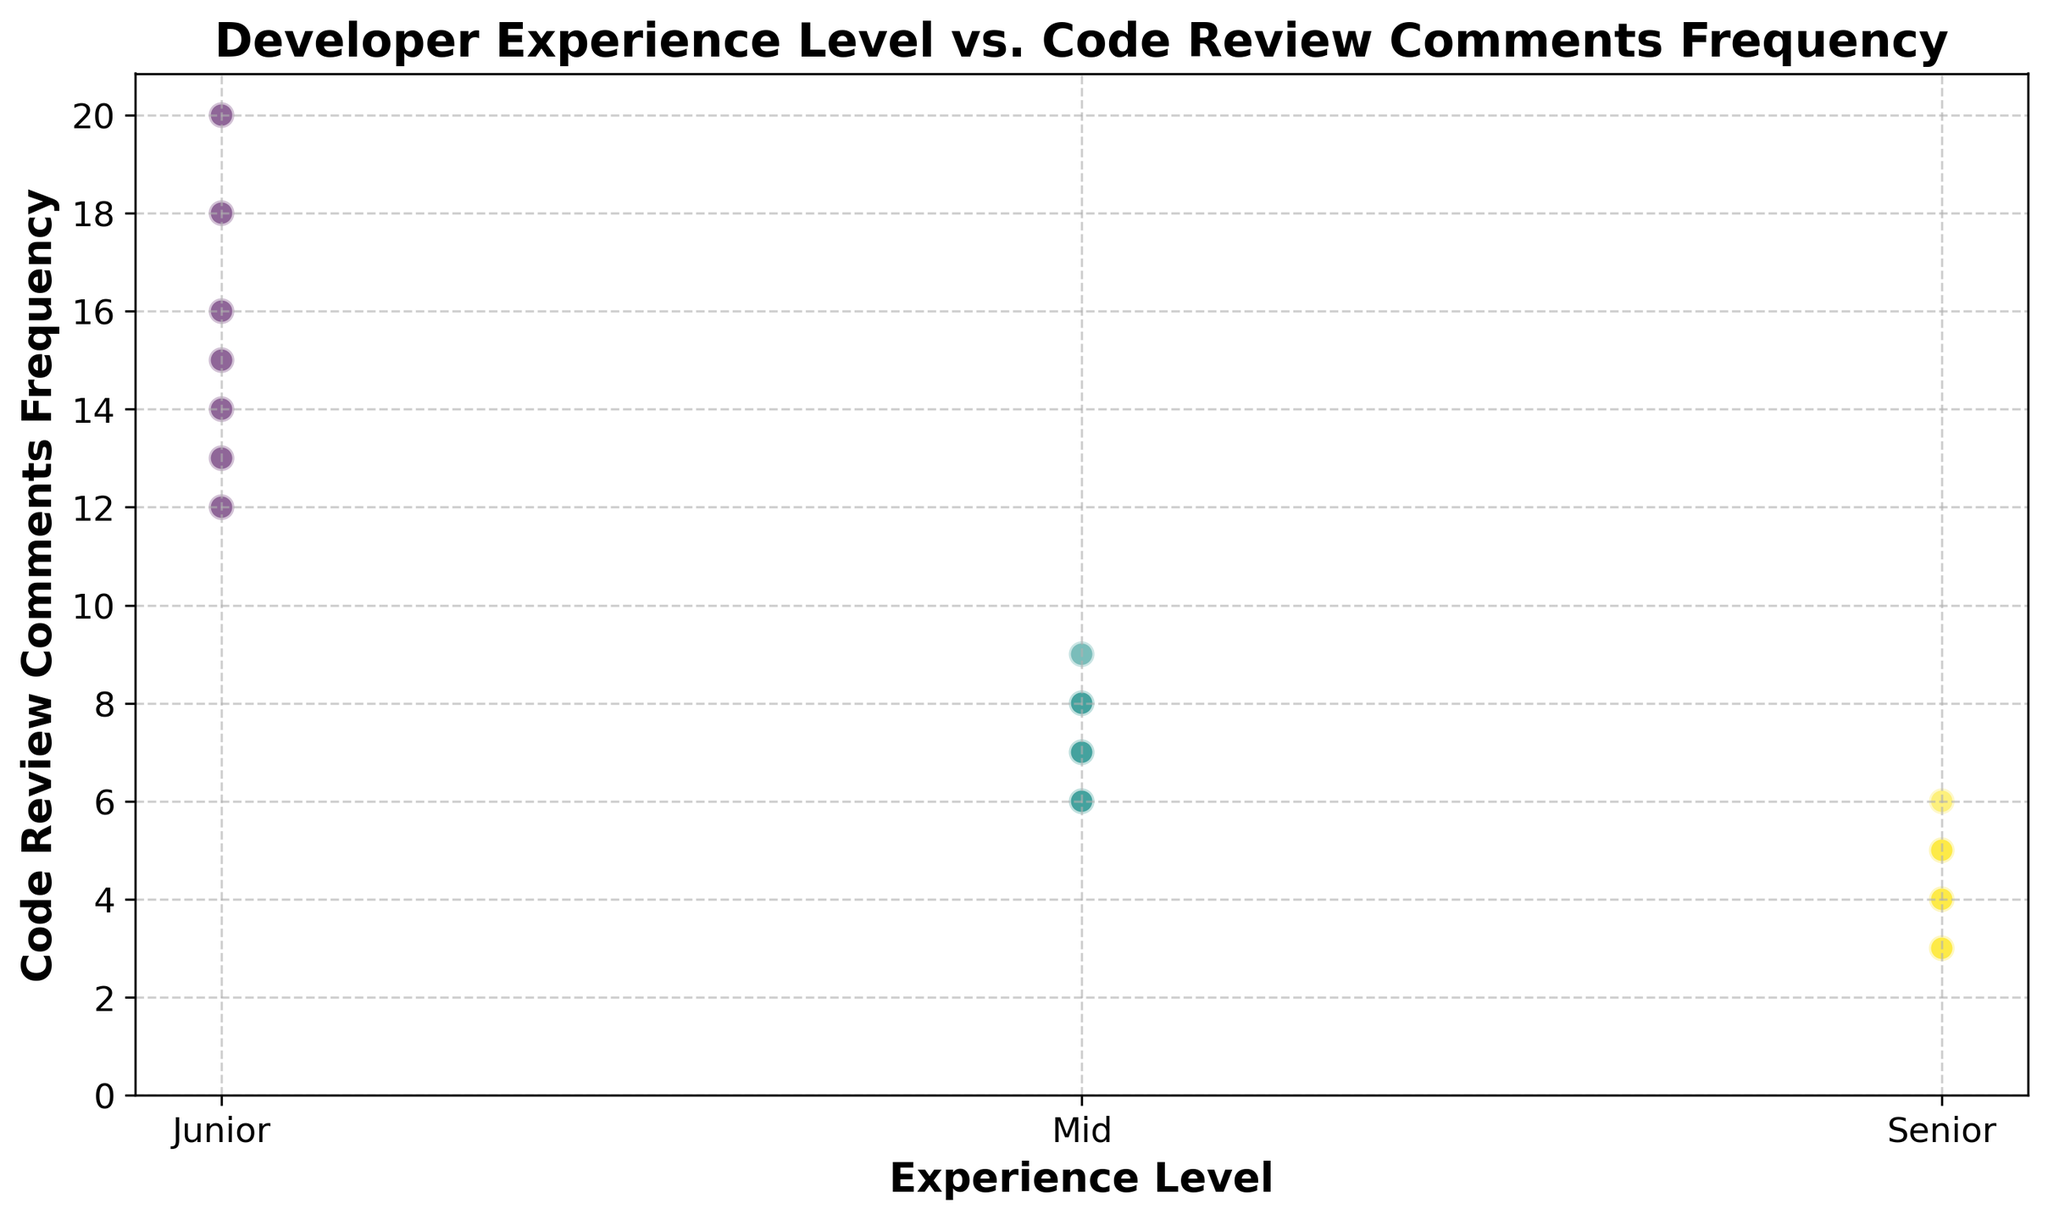What's the trend between the experience level and the frequency of code review comments? When we look at the plot, we can see that as the experience level progresses from Junior to Senior, the frequency of code review comments generally decreases. Junior developers have the highest number of code review comments, while Senior developers have the lowest.
Answer: The higher the experience level, the fewer code review comments Based on the data points, which experience level seems to receive the most frequent code review comments? By observing the scatter plot, Junior developers receive the most frequent code review comments.
Answer: Junior Comparing the midpoint experience level to the Senior level, which has more code review comments on average? From the data points in the scatter plot, Junior developers receive more code review comments than Mid developers; similarly, Mid developers receive more than Senior developers. Specifically, Mid developers have more comments than Senior developers.
Answer: Mid What is the range of code review comments seen for Junior developers? Observing the scatter points for Junior developers on the plot, the range of code review comments goes from the lowest, 12, to the highest, 20.
Answer: 12 to 20 What is the difference in the maximum code review comments between Junior and Mid developers? The maximum code review comments for Junior developers is 20, and for Mid developers, it is 9. The difference is calculated as 20 - 9.
Answer: 11 For which experience levels do the code review comments frequencies overlap? By looking at the cluster of scatter points, Junior developers' code review comment frequencies don't overlap with Senior developers. Mid developers' frequencies overlap slightly with both Junior and Senior developers.
Answer: Mid Which experience level has the most consistent range of code review comments? Since the scatter points are clustered closely together, the Senior level has the most consistent range, varying only from 3 to 6.
Answer: Senior What is the interquartile range (IQR) for code review comments in the Mid experience level? With values 8, 7, 6, 9, 7, and 6, the data set is ordered as 6, 6, 7, 7, 8, 9. The first quartile (Q1) is 6.5, and the third quartile (Q3) is 8. The IQR is Q3 - Q1.
Answer: 1.5 What proportion of Mid developers received fewer than eight code review comments? From the scatter points, out of six Mid developers, four received fewer than eight comments. The proportion is calculated as 4/6.
Answer: 2/3 